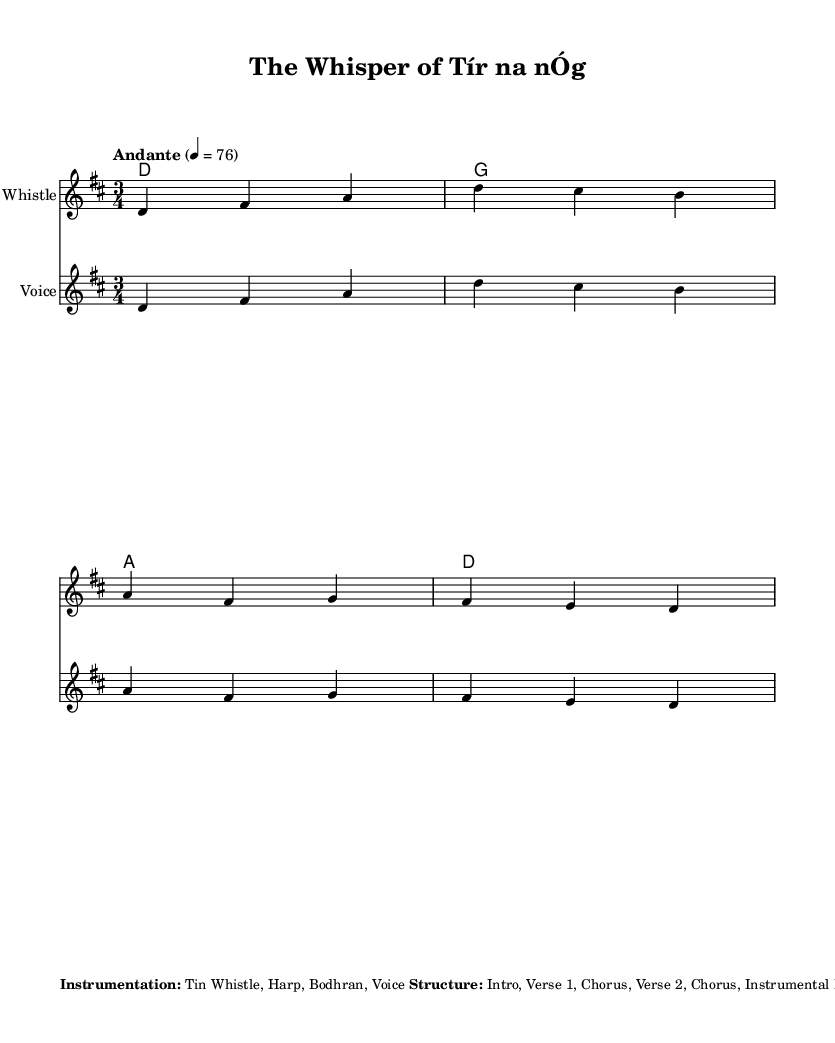What is the key signature of this music? The key signature is indicated at the beginning of the score, showing two sharps (F# and C#), which corresponds to D major.
Answer: D major What is the time signature of this piece? The time signature is located at the beginning of the score; it shows a '3' above a '4', indicating that there are three beats in each measure and the quarter note gets one beat.
Answer: 3/4 What is the tempo marking of this piece? The tempo is noted under the global settings of the score, stating "Andante" and a metronome marking of 76 beats per minute, which means a moderately slow tempo.
Answer: Andante, 76 How many instruments are indicated in the instrumentation? By counting the listed instruments in the markup section, there are four designated: Tin Whistle, Harp, Bodhran, and Voice.
Answer: Four What is the structure of the piece? The structure is detailed in the markup section, mentioning specific sections such as Intro, Verse 1, Chorus, and so forth. By following the listed components, it can be summarized as a series of sequential parts.
Answer: Intro, Verse 1, Chorus, Verse 2, Chorus, Instrumental Bridge, Chorus, Outro Which instrument plays the melody in this piece? The melody is written in the staff labeled for "Tin Whistle" as well as "Voice," indicating that both instruments can carry the melodic line. Therefore, the primary instrumental melody is for the Tin Whistle.
Answer: Tin Whistle 